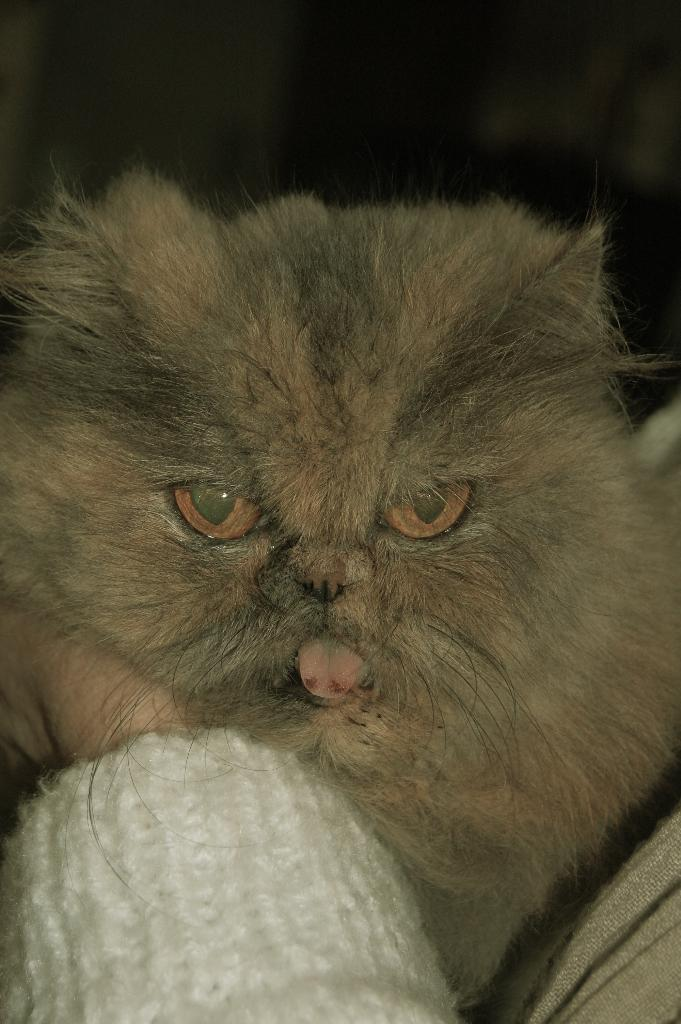What type of animal is in the image? There is a brown cat in the image. Can you describe any human elements in the image? There is a person's hand visible in the image. What is the person's hand wearing? The person's hand is wearing a white sweater. How would you describe the background of the image? The background of the image is blurred. What type of yak is visible in the image? There is no yak present in the image. What tools might the carpenter be using in the image? There is no carpenter or tools present in the image. 